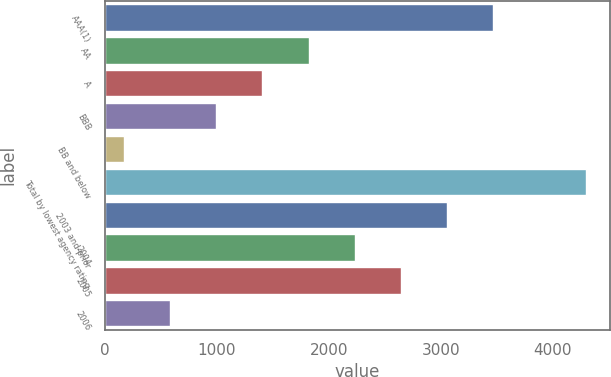Convert chart. <chart><loc_0><loc_0><loc_500><loc_500><bar_chart><fcel>AAA(1)<fcel>AA<fcel>A<fcel>BBB<fcel>BB and below<fcel>Total by lowest agency rating<fcel>2003 and prior<fcel>2004<fcel>2005<fcel>2006<nl><fcel>3470.78<fcel>1818.34<fcel>1405.23<fcel>992.12<fcel>165.9<fcel>4297<fcel>3057.67<fcel>2231.45<fcel>2644.56<fcel>579.01<nl></chart> 